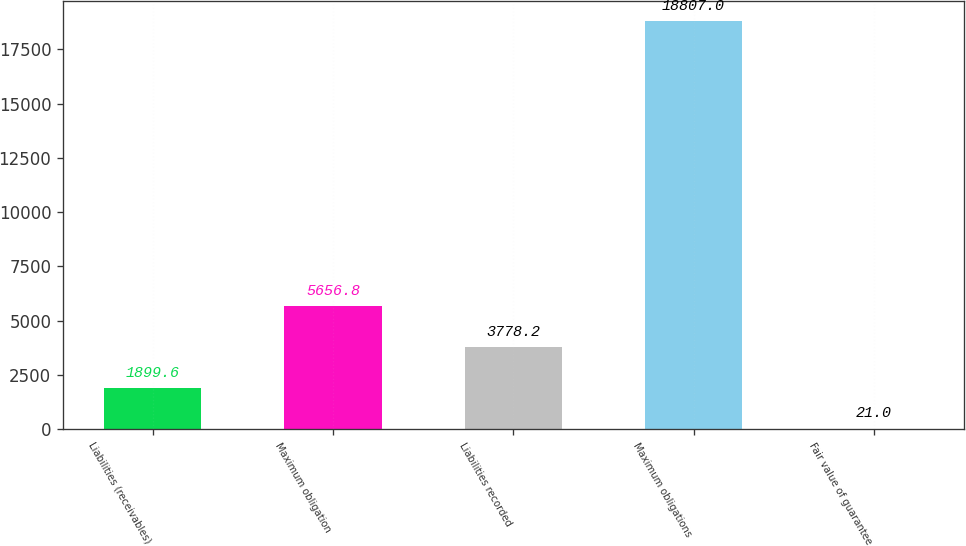<chart> <loc_0><loc_0><loc_500><loc_500><bar_chart><fcel>Liabilities (receivables)<fcel>Maximum obligation<fcel>Liabilities recorded<fcel>Maximum obligations<fcel>Fair value of guarantee<nl><fcel>1899.6<fcel>5656.8<fcel>3778.2<fcel>18807<fcel>21<nl></chart> 